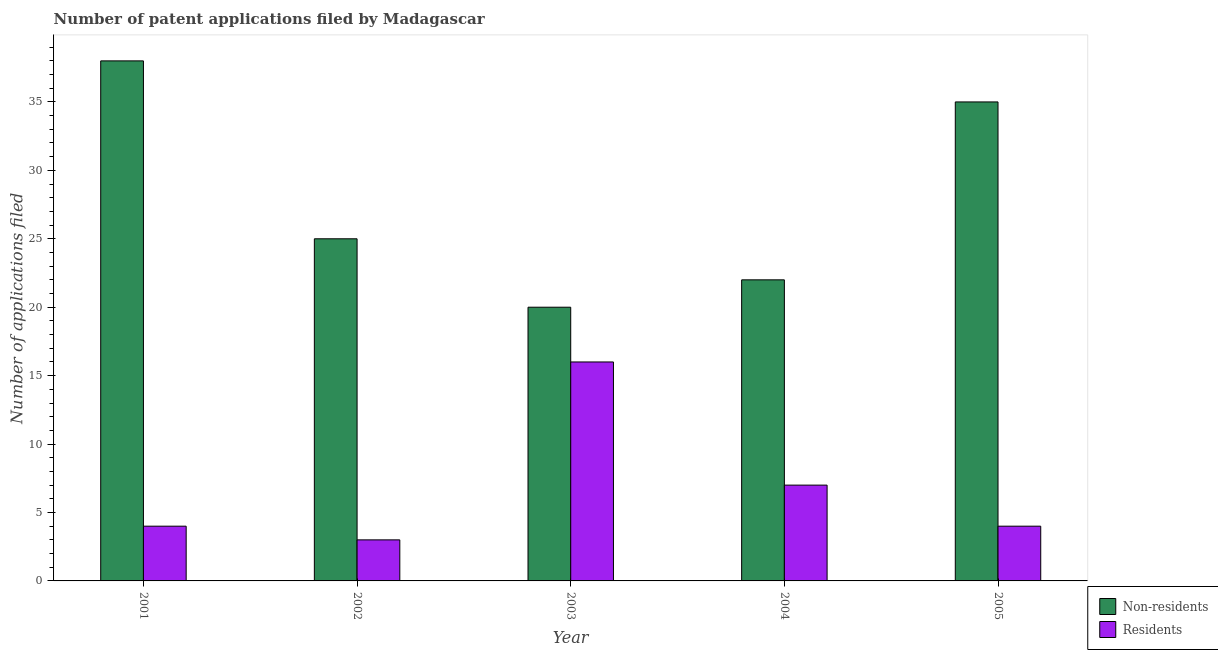How many different coloured bars are there?
Your answer should be very brief. 2. How many groups of bars are there?
Keep it short and to the point. 5. Are the number of bars per tick equal to the number of legend labels?
Offer a terse response. Yes. Are the number of bars on each tick of the X-axis equal?
Keep it short and to the point. Yes. How many bars are there on the 5th tick from the right?
Make the answer very short. 2. What is the label of the 3rd group of bars from the left?
Offer a terse response. 2003. In how many cases, is the number of bars for a given year not equal to the number of legend labels?
Keep it short and to the point. 0. What is the number of patent applications by residents in 2001?
Your answer should be very brief. 4. Across all years, what is the maximum number of patent applications by residents?
Make the answer very short. 16. Across all years, what is the minimum number of patent applications by residents?
Ensure brevity in your answer.  3. What is the total number of patent applications by residents in the graph?
Ensure brevity in your answer.  34. What is the difference between the number of patent applications by residents in 2003 and that in 2005?
Provide a short and direct response. 12. What is the difference between the number of patent applications by non residents in 2003 and the number of patent applications by residents in 2004?
Keep it short and to the point. -2. What is the ratio of the number of patent applications by non residents in 2003 to that in 2005?
Give a very brief answer. 0.57. Is the difference between the number of patent applications by residents in 2003 and 2004 greater than the difference between the number of patent applications by non residents in 2003 and 2004?
Your answer should be compact. No. What is the difference between the highest and the second highest number of patent applications by residents?
Your answer should be very brief. 9. What is the difference between the highest and the lowest number of patent applications by residents?
Offer a very short reply. 13. Is the sum of the number of patent applications by non residents in 2001 and 2002 greater than the maximum number of patent applications by residents across all years?
Offer a very short reply. Yes. What does the 2nd bar from the left in 2004 represents?
Ensure brevity in your answer.  Residents. What does the 2nd bar from the right in 2002 represents?
Ensure brevity in your answer.  Non-residents. How many bars are there?
Your response must be concise. 10. Are all the bars in the graph horizontal?
Make the answer very short. No. How many years are there in the graph?
Keep it short and to the point. 5. What is the difference between two consecutive major ticks on the Y-axis?
Ensure brevity in your answer.  5. Does the graph contain any zero values?
Give a very brief answer. No. Does the graph contain grids?
Ensure brevity in your answer.  No. Where does the legend appear in the graph?
Ensure brevity in your answer.  Bottom right. How many legend labels are there?
Offer a terse response. 2. How are the legend labels stacked?
Ensure brevity in your answer.  Vertical. What is the title of the graph?
Offer a very short reply. Number of patent applications filed by Madagascar. What is the label or title of the Y-axis?
Keep it short and to the point. Number of applications filed. What is the Number of applications filed in Non-residents in 2001?
Make the answer very short. 38. What is the Number of applications filed in Non-residents in 2002?
Your response must be concise. 25. What is the Number of applications filed of Residents in 2002?
Your answer should be compact. 3. What is the Number of applications filed in Non-residents in 2003?
Ensure brevity in your answer.  20. What is the Number of applications filed of Residents in 2003?
Your answer should be compact. 16. What is the Number of applications filed of Residents in 2004?
Keep it short and to the point. 7. Across all years, what is the maximum Number of applications filed in Residents?
Offer a terse response. 16. Across all years, what is the minimum Number of applications filed in Residents?
Provide a succinct answer. 3. What is the total Number of applications filed in Non-residents in the graph?
Keep it short and to the point. 140. What is the total Number of applications filed of Residents in the graph?
Your answer should be compact. 34. What is the difference between the Number of applications filed of Non-residents in 2001 and that in 2002?
Offer a terse response. 13. What is the difference between the Number of applications filed of Residents in 2001 and that in 2002?
Ensure brevity in your answer.  1. What is the difference between the Number of applications filed of Residents in 2001 and that in 2003?
Offer a very short reply. -12. What is the difference between the Number of applications filed of Non-residents in 2001 and that in 2005?
Your answer should be very brief. 3. What is the difference between the Number of applications filed of Residents in 2001 and that in 2005?
Offer a terse response. 0. What is the difference between the Number of applications filed of Non-residents in 2002 and that in 2003?
Give a very brief answer. 5. What is the difference between the Number of applications filed in Non-residents in 2002 and that in 2005?
Your answer should be compact. -10. What is the difference between the Number of applications filed in Residents in 2002 and that in 2005?
Provide a succinct answer. -1. What is the difference between the Number of applications filed in Non-residents in 2003 and that in 2004?
Ensure brevity in your answer.  -2. What is the difference between the Number of applications filed of Residents in 2003 and that in 2004?
Offer a very short reply. 9. What is the difference between the Number of applications filed of Residents in 2003 and that in 2005?
Give a very brief answer. 12. What is the difference between the Number of applications filed of Non-residents in 2004 and that in 2005?
Your response must be concise. -13. What is the difference between the Number of applications filed in Residents in 2004 and that in 2005?
Give a very brief answer. 3. What is the difference between the Number of applications filed of Non-residents in 2001 and the Number of applications filed of Residents in 2003?
Provide a succinct answer. 22. What is the difference between the Number of applications filed of Non-residents in 2001 and the Number of applications filed of Residents in 2005?
Offer a terse response. 34. What is the difference between the Number of applications filed of Non-residents in 2002 and the Number of applications filed of Residents in 2004?
Provide a succinct answer. 18. What is the difference between the Number of applications filed of Non-residents in 2003 and the Number of applications filed of Residents in 2004?
Provide a succinct answer. 13. What is the difference between the Number of applications filed in Non-residents in 2004 and the Number of applications filed in Residents in 2005?
Keep it short and to the point. 18. What is the average Number of applications filed in Non-residents per year?
Keep it short and to the point. 28. In the year 2001, what is the difference between the Number of applications filed of Non-residents and Number of applications filed of Residents?
Your answer should be compact. 34. What is the ratio of the Number of applications filed of Non-residents in 2001 to that in 2002?
Provide a short and direct response. 1.52. What is the ratio of the Number of applications filed in Residents in 2001 to that in 2002?
Your answer should be very brief. 1.33. What is the ratio of the Number of applications filed of Non-residents in 2001 to that in 2003?
Keep it short and to the point. 1.9. What is the ratio of the Number of applications filed in Non-residents in 2001 to that in 2004?
Offer a very short reply. 1.73. What is the ratio of the Number of applications filed of Non-residents in 2001 to that in 2005?
Your answer should be very brief. 1.09. What is the ratio of the Number of applications filed in Non-residents in 2002 to that in 2003?
Keep it short and to the point. 1.25. What is the ratio of the Number of applications filed of Residents in 2002 to that in 2003?
Provide a succinct answer. 0.19. What is the ratio of the Number of applications filed in Non-residents in 2002 to that in 2004?
Make the answer very short. 1.14. What is the ratio of the Number of applications filed of Residents in 2002 to that in 2004?
Provide a succinct answer. 0.43. What is the ratio of the Number of applications filed in Residents in 2002 to that in 2005?
Keep it short and to the point. 0.75. What is the ratio of the Number of applications filed of Non-residents in 2003 to that in 2004?
Make the answer very short. 0.91. What is the ratio of the Number of applications filed in Residents in 2003 to that in 2004?
Provide a succinct answer. 2.29. What is the ratio of the Number of applications filed in Non-residents in 2003 to that in 2005?
Make the answer very short. 0.57. What is the ratio of the Number of applications filed of Non-residents in 2004 to that in 2005?
Your answer should be very brief. 0.63. What is the ratio of the Number of applications filed of Residents in 2004 to that in 2005?
Offer a terse response. 1.75. What is the difference between the highest and the second highest Number of applications filed in Non-residents?
Ensure brevity in your answer.  3. What is the difference between the highest and the second highest Number of applications filed in Residents?
Keep it short and to the point. 9. What is the difference between the highest and the lowest Number of applications filed of Non-residents?
Provide a succinct answer. 18. 